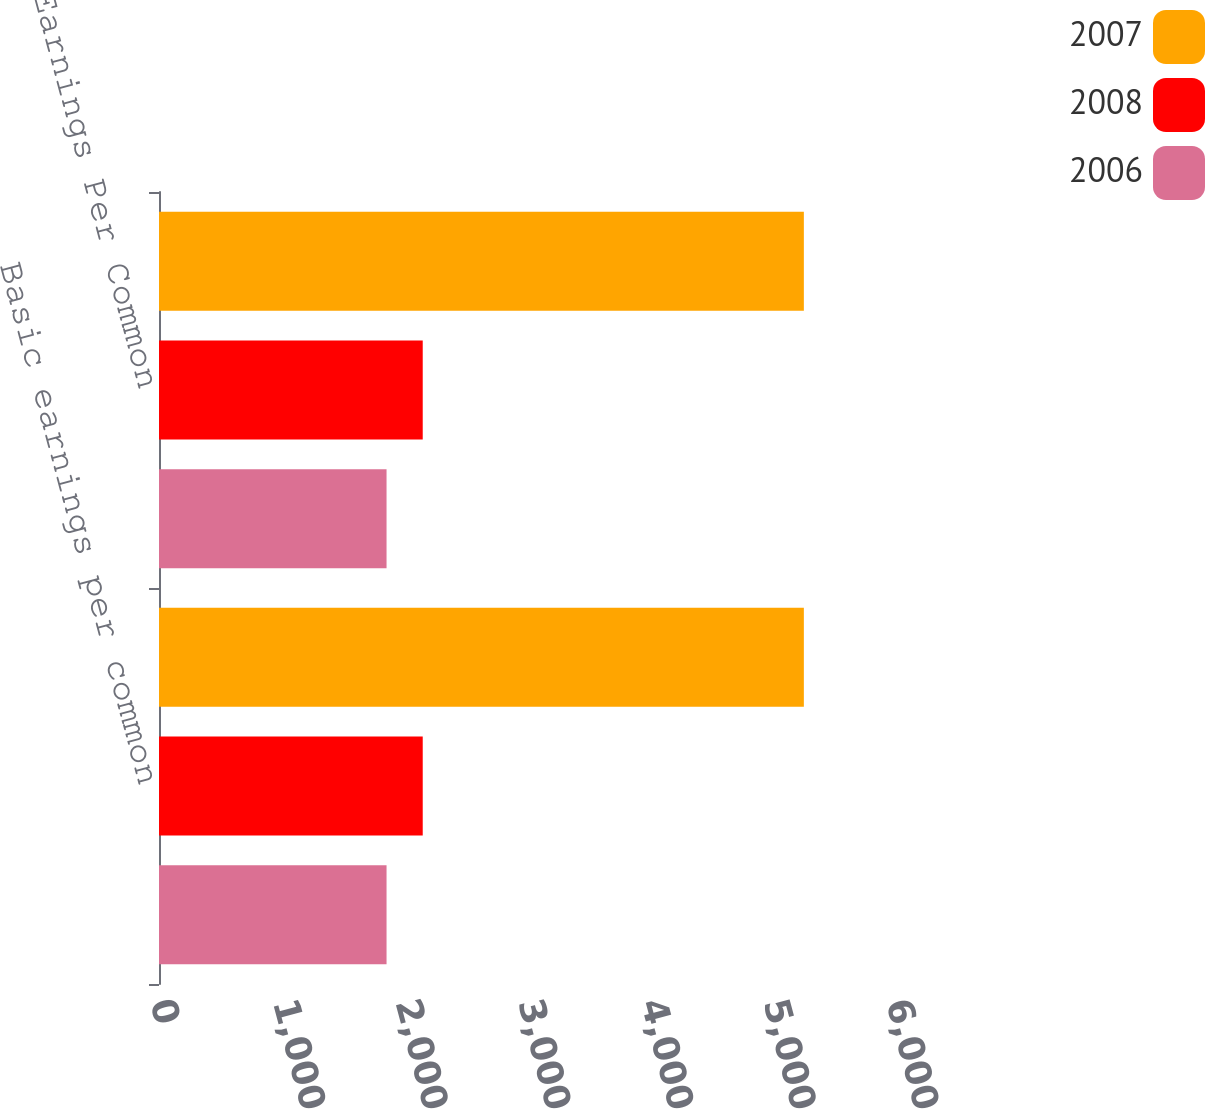Convert chart. <chart><loc_0><loc_0><loc_500><loc_500><stacked_bar_chart><ecel><fcel>Basic earnings per common<fcel>Diluted Earnings Per Common<nl><fcel>2007<fcel>5257<fcel>5257<nl><fcel>2008<fcel>2150<fcel>2150<nl><fcel>2006<fcel>1855<fcel>1855<nl></chart> 